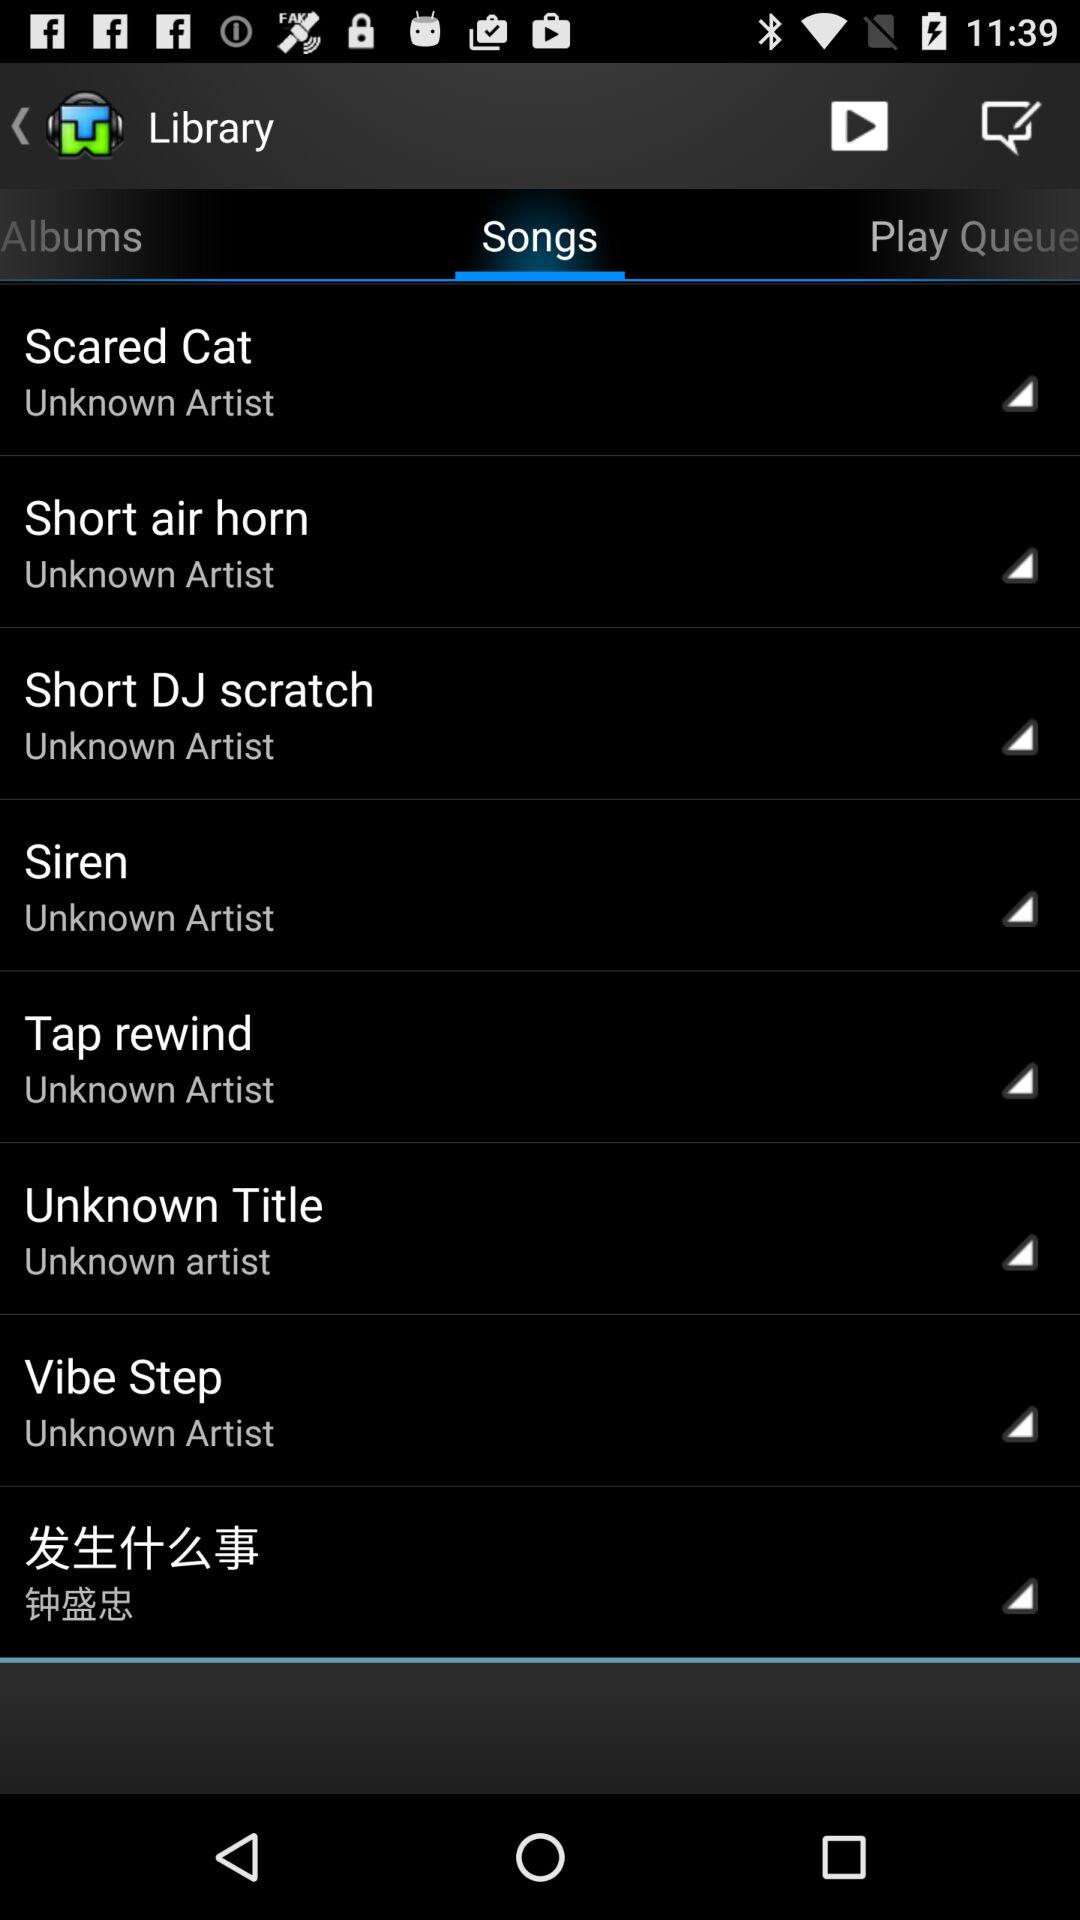Who is the artist of "Siren"? The artist of "Siren" is unknown. 